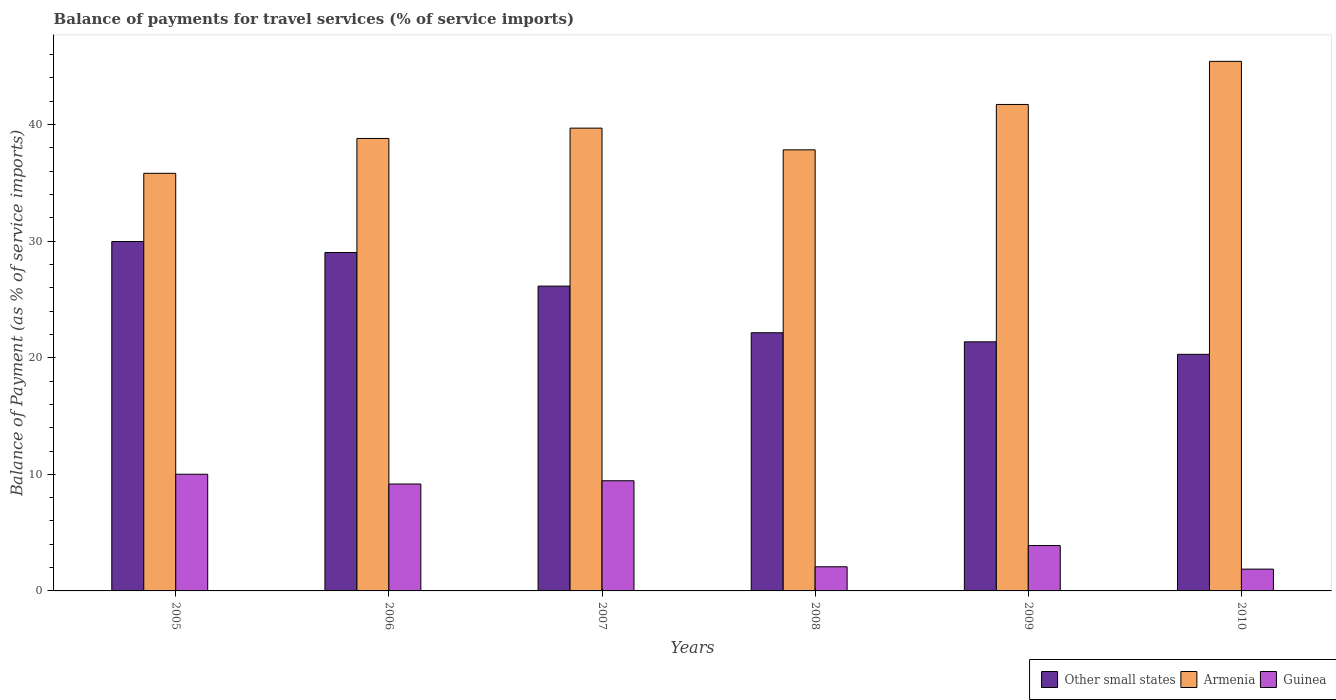How many different coloured bars are there?
Provide a short and direct response. 3. Are the number of bars per tick equal to the number of legend labels?
Keep it short and to the point. Yes. What is the label of the 5th group of bars from the left?
Your response must be concise. 2009. What is the balance of payments for travel services in Armenia in 2008?
Provide a short and direct response. 37.84. Across all years, what is the maximum balance of payments for travel services in Armenia?
Keep it short and to the point. 45.43. Across all years, what is the minimum balance of payments for travel services in Armenia?
Give a very brief answer. 35.82. What is the total balance of payments for travel services in Armenia in the graph?
Your answer should be compact. 239.32. What is the difference between the balance of payments for travel services in Guinea in 2006 and that in 2007?
Keep it short and to the point. -0.28. What is the difference between the balance of payments for travel services in Armenia in 2005 and the balance of payments for travel services in Guinea in 2006?
Provide a short and direct response. 26.65. What is the average balance of payments for travel services in Armenia per year?
Your answer should be compact. 39.89. In the year 2007, what is the difference between the balance of payments for travel services in Other small states and balance of payments for travel services in Armenia?
Your response must be concise. -13.55. In how many years, is the balance of payments for travel services in Other small states greater than 20 %?
Make the answer very short. 6. What is the ratio of the balance of payments for travel services in Armenia in 2006 to that in 2009?
Your answer should be compact. 0.93. Is the difference between the balance of payments for travel services in Other small states in 2009 and 2010 greater than the difference between the balance of payments for travel services in Armenia in 2009 and 2010?
Give a very brief answer. Yes. What is the difference between the highest and the second highest balance of payments for travel services in Armenia?
Offer a very short reply. 3.7. What is the difference between the highest and the lowest balance of payments for travel services in Armenia?
Ensure brevity in your answer.  9.6. In how many years, is the balance of payments for travel services in Other small states greater than the average balance of payments for travel services in Other small states taken over all years?
Provide a succinct answer. 3. Is the sum of the balance of payments for travel services in Armenia in 2005 and 2006 greater than the maximum balance of payments for travel services in Guinea across all years?
Provide a short and direct response. Yes. What does the 2nd bar from the left in 2008 represents?
Your answer should be compact. Armenia. What does the 2nd bar from the right in 2008 represents?
Provide a short and direct response. Armenia. What is the difference between two consecutive major ticks on the Y-axis?
Provide a short and direct response. 10. Are the values on the major ticks of Y-axis written in scientific E-notation?
Provide a short and direct response. No. Does the graph contain grids?
Offer a very short reply. No. Where does the legend appear in the graph?
Keep it short and to the point. Bottom right. How many legend labels are there?
Offer a very short reply. 3. What is the title of the graph?
Your answer should be very brief. Balance of payments for travel services (% of service imports). Does "Panama" appear as one of the legend labels in the graph?
Ensure brevity in your answer.  No. What is the label or title of the Y-axis?
Your answer should be compact. Balance of Payment (as % of service imports). What is the Balance of Payment (as % of service imports) of Other small states in 2005?
Ensure brevity in your answer.  29.97. What is the Balance of Payment (as % of service imports) of Armenia in 2005?
Make the answer very short. 35.82. What is the Balance of Payment (as % of service imports) of Guinea in 2005?
Ensure brevity in your answer.  10.01. What is the Balance of Payment (as % of service imports) of Other small states in 2006?
Provide a short and direct response. 29.03. What is the Balance of Payment (as % of service imports) in Armenia in 2006?
Your response must be concise. 38.81. What is the Balance of Payment (as % of service imports) of Guinea in 2006?
Your answer should be compact. 9.17. What is the Balance of Payment (as % of service imports) in Other small states in 2007?
Provide a short and direct response. 26.15. What is the Balance of Payment (as % of service imports) of Armenia in 2007?
Your answer should be very brief. 39.7. What is the Balance of Payment (as % of service imports) of Guinea in 2007?
Offer a very short reply. 9.45. What is the Balance of Payment (as % of service imports) of Other small states in 2008?
Give a very brief answer. 22.15. What is the Balance of Payment (as % of service imports) in Armenia in 2008?
Make the answer very short. 37.84. What is the Balance of Payment (as % of service imports) of Guinea in 2008?
Your answer should be very brief. 2.07. What is the Balance of Payment (as % of service imports) of Other small states in 2009?
Offer a very short reply. 21.37. What is the Balance of Payment (as % of service imports) of Armenia in 2009?
Offer a very short reply. 41.73. What is the Balance of Payment (as % of service imports) in Guinea in 2009?
Keep it short and to the point. 3.89. What is the Balance of Payment (as % of service imports) in Other small states in 2010?
Make the answer very short. 20.3. What is the Balance of Payment (as % of service imports) in Armenia in 2010?
Your response must be concise. 45.43. What is the Balance of Payment (as % of service imports) in Guinea in 2010?
Your answer should be compact. 1.87. Across all years, what is the maximum Balance of Payment (as % of service imports) of Other small states?
Your response must be concise. 29.97. Across all years, what is the maximum Balance of Payment (as % of service imports) of Armenia?
Your answer should be very brief. 45.43. Across all years, what is the maximum Balance of Payment (as % of service imports) of Guinea?
Your answer should be compact. 10.01. Across all years, what is the minimum Balance of Payment (as % of service imports) of Other small states?
Provide a succinct answer. 20.3. Across all years, what is the minimum Balance of Payment (as % of service imports) in Armenia?
Your response must be concise. 35.82. Across all years, what is the minimum Balance of Payment (as % of service imports) in Guinea?
Provide a succinct answer. 1.87. What is the total Balance of Payment (as % of service imports) in Other small states in the graph?
Make the answer very short. 148.96. What is the total Balance of Payment (as % of service imports) of Armenia in the graph?
Your answer should be compact. 239.32. What is the total Balance of Payment (as % of service imports) of Guinea in the graph?
Keep it short and to the point. 36.46. What is the difference between the Balance of Payment (as % of service imports) in Other small states in 2005 and that in 2006?
Offer a very short reply. 0.94. What is the difference between the Balance of Payment (as % of service imports) in Armenia in 2005 and that in 2006?
Offer a very short reply. -2.99. What is the difference between the Balance of Payment (as % of service imports) in Guinea in 2005 and that in 2006?
Make the answer very short. 0.84. What is the difference between the Balance of Payment (as % of service imports) in Other small states in 2005 and that in 2007?
Your answer should be compact. 3.83. What is the difference between the Balance of Payment (as % of service imports) in Armenia in 2005 and that in 2007?
Give a very brief answer. -3.88. What is the difference between the Balance of Payment (as % of service imports) in Guinea in 2005 and that in 2007?
Provide a short and direct response. 0.56. What is the difference between the Balance of Payment (as % of service imports) of Other small states in 2005 and that in 2008?
Offer a very short reply. 7.83. What is the difference between the Balance of Payment (as % of service imports) in Armenia in 2005 and that in 2008?
Your answer should be compact. -2.01. What is the difference between the Balance of Payment (as % of service imports) of Guinea in 2005 and that in 2008?
Ensure brevity in your answer.  7.94. What is the difference between the Balance of Payment (as % of service imports) in Other small states in 2005 and that in 2009?
Make the answer very short. 8.61. What is the difference between the Balance of Payment (as % of service imports) in Armenia in 2005 and that in 2009?
Ensure brevity in your answer.  -5.91. What is the difference between the Balance of Payment (as % of service imports) in Guinea in 2005 and that in 2009?
Offer a terse response. 6.12. What is the difference between the Balance of Payment (as % of service imports) in Other small states in 2005 and that in 2010?
Ensure brevity in your answer.  9.68. What is the difference between the Balance of Payment (as % of service imports) in Armenia in 2005 and that in 2010?
Provide a short and direct response. -9.6. What is the difference between the Balance of Payment (as % of service imports) of Guinea in 2005 and that in 2010?
Keep it short and to the point. 8.14. What is the difference between the Balance of Payment (as % of service imports) in Other small states in 2006 and that in 2007?
Provide a short and direct response. 2.88. What is the difference between the Balance of Payment (as % of service imports) in Armenia in 2006 and that in 2007?
Provide a short and direct response. -0.89. What is the difference between the Balance of Payment (as % of service imports) in Guinea in 2006 and that in 2007?
Your answer should be compact. -0.28. What is the difference between the Balance of Payment (as % of service imports) of Other small states in 2006 and that in 2008?
Your response must be concise. 6.88. What is the difference between the Balance of Payment (as % of service imports) of Armenia in 2006 and that in 2008?
Provide a short and direct response. 0.98. What is the difference between the Balance of Payment (as % of service imports) in Guinea in 2006 and that in 2008?
Your response must be concise. 7.1. What is the difference between the Balance of Payment (as % of service imports) in Other small states in 2006 and that in 2009?
Your answer should be very brief. 7.67. What is the difference between the Balance of Payment (as % of service imports) in Armenia in 2006 and that in 2009?
Your response must be concise. -2.92. What is the difference between the Balance of Payment (as % of service imports) of Guinea in 2006 and that in 2009?
Make the answer very short. 5.28. What is the difference between the Balance of Payment (as % of service imports) in Other small states in 2006 and that in 2010?
Provide a short and direct response. 8.73. What is the difference between the Balance of Payment (as % of service imports) of Armenia in 2006 and that in 2010?
Your answer should be very brief. -6.61. What is the difference between the Balance of Payment (as % of service imports) in Guinea in 2006 and that in 2010?
Your response must be concise. 7.3. What is the difference between the Balance of Payment (as % of service imports) of Other small states in 2007 and that in 2008?
Keep it short and to the point. 4. What is the difference between the Balance of Payment (as % of service imports) in Armenia in 2007 and that in 2008?
Give a very brief answer. 1.86. What is the difference between the Balance of Payment (as % of service imports) in Guinea in 2007 and that in 2008?
Your response must be concise. 7.38. What is the difference between the Balance of Payment (as % of service imports) of Other small states in 2007 and that in 2009?
Keep it short and to the point. 4.78. What is the difference between the Balance of Payment (as % of service imports) in Armenia in 2007 and that in 2009?
Make the answer very short. -2.03. What is the difference between the Balance of Payment (as % of service imports) in Guinea in 2007 and that in 2009?
Offer a terse response. 5.56. What is the difference between the Balance of Payment (as % of service imports) in Other small states in 2007 and that in 2010?
Your answer should be compact. 5.85. What is the difference between the Balance of Payment (as % of service imports) in Armenia in 2007 and that in 2010?
Your answer should be very brief. -5.73. What is the difference between the Balance of Payment (as % of service imports) of Guinea in 2007 and that in 2010?
Provide a short and direct response. 7.58. What is the difference between the Balance of Payment (as % of service imports) in Other small states in 2008 and that in 2009?
Keep it short and to the point. 0.78. What is the difference between the Balance of Payment (as % of service imports) in Armenia in 2008 and that in 2009?
Your answer should be compact. -3.89. What is the difference between the Balance of Payment (as % of service imports) of Guinea in 2008 and that in 2009?
Your answer should be very brief. -1.82. What is the difference between the Balance of Payment (as % of service imports) of Other small states in 2008 and that in 2010?
Keep it short and to the point. 1.85. What is the difference between the Balance of Payment (as % of service imports) of Armenia in 2008 and that in 2010?
Provide a short and direct response. -7.59. What is the difference between the Balance of Payment (as % of service imports) in Guinea in 2008 and that in 2010?
Your response must be concise. 0.2. What is the difference between the Balance of Payment (as % of service imports) in Other small states in 2009 and that in 2010?
Your answer should be compact. 1.07. What is the difference between the Balance of Payment (as % of service imports) of Armenia in 2009 and that in 2010?
Keep it short and to the point. -3.7. What is the difference between the Balance of Payment (as % of service imports) of Guinea in 2009 and that in 2010?
Your answer should be compact. 2.02. What is the difference between the Balance of Payment (as % of service imports) in Other small states in 2005 and the Balance of Payment (as % of service imports) in Armenia in 2006?
Your answer should be compact. -8.84. What is the difference between the Balance of Payment (as % of service imports) of Other small states in 2005 and the Balance of Payment (as % of service imports) of Guinea in 2006?
Offer a terse response. 20.8. What is the difference between the Balance of Payment (as % of service imports) in Armenia in 2005 and the Balance of Payment (as % of service imports) in Guinea in 2006?
Keep it short and to the point. 26.65. What is the difference between the Balance of Payment (as % of service imports) of Other small states in 2005 and the Balance of Payment (as % of service imports) of Armenia in 2007?
Make the answer very short. -9.72. What is the difference between the Balance of Payment (as % of service imports) of Other small states in 2005 and the Balance of Payment (as % of service imports) of Guinea in 2007?
Make the answer very short. 20.52. What is the difference between the Balance of Payment (as % of service imports) in Armenia in 2005 and the Balance of Payment (as % of service imports) in Guinea in 2007?
Keep it short and to the point. 26.37. What is the difference between the Balance of Payment (as % of service imports) of Other small states in 2005 and the Balance of Payment (as % of service imports) of Armenia in 2008?
Your answer should be compact. -7.86. What is the difference between the Balance of Payment (as % of service imports) in Other small states in 2005 and the Balance of Payment (as % of service imports) in Guinea in 2008?
Offer a very short reply. 27.9. What is the difference between the Balance of Payment (as % of service imports) in Armenia in 2005 and the Balance of Payment (as % of service imports) in Guinea in 2008?
Your answer should be compact. 33.75. What is the difference between the Balance of Payment (as % of service imports) of Other small states in 2005 and the Balance of Payment (as % of service imports) of Armenia in 2009?
Provide a short and direct response. -11.76. What is the difference between the Balance of Payment (as % of service imports) of Other small states in 2005 and the Balance of Payment (as % of service imports) of Guinea in 2009?
Make the answer very short. 26.08. What is the difference between the Balance of Payment (as % of service imports) in Armenia in 2005 and the Balance of Payment (as % of service imports) in Guinea in 2009?
Provide a succinct answer. 31.93. What is the difference between the Balance of Payment (as % of service imports) of Other small states in 2005 and the Balance of Payment (as % of service imports) of Armenia in 2010?
Ensure brevity in your answer.  -15.45. What is the difference between the Balance of Payment (as % of service imports) of Other small states in 2005 and the Balance of Payment (as % of service imports) of Guinea in 2010?
Offer a terse response. 28.1. What is the difference between the Balance of Payment (as % of service imports) in Armenia in 2005 and the Balance of Payment (as % of service imports) in Guinea in 2010?
Your answer should be compact. 33.95. What is the difference between the Balance of Payment (as % of service imports) in Other small states in 2006 and the Balance of Payment (as % of service imports) in Armenia in 2007?
Provide a succinct answer. -10.67. What is the difference between the Balance of Payment (as % of service imports) of Other small states in 2006 and the Balance of Payment (as % of service imports) of Guinea in 2007?
Give a very brief answer. 19.58. What is the difference between the Balance of Payment (as % of service imports) in Armenia in 2006 and the Balance of Payment (as % of service imports) in Guinea in 2007?
Make the answer very short. 29.36. What is the difference between the Balance of Payment (as % of service imports) of Other small states in 2006 and the Balance of Payment (as % of service imports) of Armenia in 2008?
Ensure brevity in your answer.  -8.81. What is the difference between the Balance of Payment (as % of service imports) of Other small states in 2006 and the Balance of Payment (as % of service imports) of Guinea in 2008?
Offer a terse response. 26.96. What is the difference between the Balance of Payment (as % of service imports) of Armenia in 2006 and the Balance of Payment (as % of service imports) of Guinea in 2008?
Make the answer very short. 36.74. What is the difference between the Balance of Payment (as % of service imports) of Other small states in 2006 and the Balance of Payment (as % of service imports) of Armenia in 2009?
Your answer should be very brief. -12.7. What is the difference between the Balance of Payment (as % of service imports) in Other small states in 2006 and the Balance of Payment (as % of service imports) in Guinea in 2009?
Your answer should be compact. 25.14. What is the difference between the Balance of Payment (as % of service imports) of Armenia in 2006 and the Balance of Payment (as % of service imports) of Guinea in 2009?
Your answer should be very brief. 34.92. What is the difference between the Balance of Payment (as % of service imports) of Other small states in 2006 and the Balance of Payment (as % of service imports) of Armenia in 2010?
Your answer should be very brief. -16.4. What is the difference between the Balance of Payment (as % of service imports) of Other small states in 2006 and the Balance of Payment (as % of service imports) of Guinea in 2010?
Your answer should be very brief. 27.16. What is the difference between the Balance of Payment (as % of service imports) of Armenia in 2006 and the Balance of Payment (as % of service imports) of Guinea in 2010?
Make the answer very short. 36.94. What is the difference between the Balance of Payment (as % of service imports) of Other small states in 2007 and the Balance of Payment (as % of service imports) of Armenia in 2008?
Offer a very short reply. -11.69. What is the difference between the Balance of Payment (as % of service imports) of Other small states in 2007 and the Balance of Payment (as % of service imports) of Guinea in 2008?
Your answer should be compact. 24.08. What is the difference between the Balance of Payment (as % of service imports) in Armenia in 2007 and the Balance of Payment (as % of service imports) in Guinea in 2008?
Offer a terse response. 37.63. What is the difference between the Balance of Payment (as % of service imports) of Other small states in 2007 and the Balance of Payment (as % of service imports) of Armenia in 2009?
Provide a succinct answer. -15.58. What is the difference between the Balance of Payment (as % of service imports) in Other small states in 2007 and the Balance of Payment (as % of service imports) in Guinea in 2009?
Offer a very short reply. 22.26. What is the difference between the Balance of Payment (as % of service imports) in Armenia in 2007 and the Balance of Payment (as % of service imports) in Guinea in 2009?
Keep it short and to the point. 35.81. What is the difference between the Balance of Payment (as % of service imports) in Other small states in 2007 and the Balance of Payment (as % of service imports) in Armenia in 2010?
Give a very brief answer. -19.28. What is the difference between the Balance of Payment (as % of service imports) in Other small states in 2007 and the Balance of Payment (as % of service imports) in Guinea in 2010?
Make the answer very short. 24.28. What is the difference between the Balance of Payment (as % of service imports) of Armenia in 2007 and the Balance of Payment (as % of service imports) of Guinea in 2010?
Provide a succinct answer. 37.83. What is the difference between the Balance of Payment (as % of service imports) of Other small states in 2008 and the Balance of Payment (as % of service imports) of Armenia in 2009?
Make the answer very short. -19.58. What is the difference between the Balance of Payment (as % of service imports) in Other small states in 2008 and the Balance of Payment (as % of service imports) in Guinea in 2009?
Offer a very short reply. 18.25. What is the difference between the Balance of Payment (as % of service imports) in Armenia in 2008 and the Balance of Payment (as % of service imports) in Guinea in 2009?
Your answer should be compact. 33.94. What is the difference between the Balance of Payment (as % of service imports) of Other small states in 2008 and the Balance of Payment (as % of service imports) of Armenia in 2010?
Provide a short and direct response. -23.28. What is the difference between the Balance of Payment (as % of service imports) of Other small states in 2008 and the Balance of Payment (as % of service imports) of Guinea in 2010?
Offer a terse response. 20.28. What is the difference between the Balance of Payment (as % of service imports) in Armenia in 2008 and the Balance of Payment (as % of service imports) in Guinea in 2010?
Ensure brevity in your answer.  35.97. What is the difference between the Balance of Payment (as % of service imports) of Other small states in 2009 and the Balance of Payment (as % of service imports) of Armenia in 2010?
Offer a terse response. -24.06. What is the difference between the Balance of Payment (as % of service imports) in Other small states in 2009 and the Balance of Payment (as % of service imports) in Guinea in 2010?
Make the answer very short. 19.49. What is the difference between the Balance of Payment (as % of service imports) in Armenia in 2009 and the Balance of Payment (as % of service imports) in Guinea in 2010?
Offer a very short reply. 39.86. What is the average Balance of Payment (as % of service imports) in Other small states per year?
Give a very brief answer. 24.83. What is the average Balance of Payment (as % of service imports) of Armenia per year?
Keep it short and to the point. 39.89. What is the average Balance of Payment (as % of service imports) of Guinea per year?
Your answer should be compact. 6.08. In the year 2005, what is the difference between the Balance of Payment (as % of service imports) of Other small states and Balance of Payment (as % of service imports) of Armenia?
Keep it short and to the point. -5.85. In the year 2005, what is the difference between the Balance of Payment (as % of service imports) in Other small states and Balance of Payment (as % of service imports) in Guinea?
Give a very brief answer. 19.97. In the year 2005, what is the difference between the Balance of Payment (as % of service imports) in Armenia and Balance of Payment (as % of service imports) in Guinea?
Your answer should be compact. 25.81. In the year 2006, what is the difference between the Balance of Payment (as % of service imports) of Other small states and Balance of Payment (as % of service imports) of Armenia?
Offer a terse response. -9.78. In the year 2006, what is the difference between the Balance of Payment (as % of service imports) of Other small states and Balance of Payment (as % of service imports) of Guinea?
Your response must be concise. 19.86. In the year 2006, what is the difference between the Balance of Payment (as % of service imports) in Armenia and Balance of Payment (as % of service imports) in Guinea?
Provide a short and direct response. 29.64. In the year 2007, what is the difference between the Balance of Payment (as % of service imports) in Other small states and Balance of Payment (as % of service imports) in Armenia?
Offer a very short reply. -13.55. In the year 2007, what is the difference between the Balance of Payment (as % of service imports) of Other small states and Balance of Payment (as % of service imports) of Guinea?
Your response must be concise. 16.7. In the year 2007, what is the difference between the Balance of Payment (as % of service imports) of Armenia and Balance of Payment (as % of service imports) of Guinea?
Offer a terse response. 30.25. In the year 2008, what is the difference between the Balance of Payment (as % of service imports) of Other small states and Balance of Payment (as % of service imports) of Armenia?
Provide a short and direct response. -15.69. In the year 2008, what is the difference between the Balance of Payment (as % of service imports) of Other small states and Balance of Payment (as % of service imports) of Guinea?
Your response must be concise. 20.08. In the year 2008, what is the difference between the Balance of Payment (as % of service imports) in Armenia and Balance of Payment (as % of service imports) in Guinea?
Your answer should be very brief. 35.77. In the year 2009, what is the difference between the Balance of Payment (as % of service imports) in Other small states and Balance of Payment (as % of service imports) in Armenia?
Give a very brief answer. -20.36. In the year 2009, what is the difference between the Balance of Payment (as % of service imports) of Other small states and Balance of Payment (as % of service imports) of Guinea?
Make the answer very short. 17.47. In the year 2009, what is the difference between the Balance of Payment (as % of service imports) in Armenia and Balance of Payment (as % of service imports) in Guinea?
Make the answer very short. 37.84. In the year 2010, what is the difference between the Balance of Payment (as % of service imports) in Other small states and Balance of Payment (as % of service imports) in Armenia?
Keep it short and to the point. -25.13. In the year 2010, what is the difference between the Balance of Payment (as % of service imports) in Other small states and Balance of Payment (as % of service imports) in Guinea?
Your answer should be compact. 18.43. In the year 2010, what is the difference between the Balance of Payment (as % of service imports) of Armenia and Balance of Payment (as % of service imports) of Guinea?
Provide a succinct answer. 43.56. What is the ratio of the Balance of Payment (as % of service imports) of Other small states in 2005 to that in 2006?
Your answer should be compact. 1.03. What is the ratio of the Balance of Payment (as % of service imports) in Armenia in 2005 to that in 2006?
Offer a terse response. 0.92. What is the ratio of the Balance of Payment (as % of service imports) in Guinea in 2005 to that in 2006?
Keep it short and to the point. 1.09. What is the ratio of the Balance of Payment (as % of service imports) in Other small states in 2005 to that in 2007?
Make the answer very short. 1.15. What is the ratio of the Balance of Payment (as % of service imports) in Armenia in 2005 to that in 2007?
Make the answer very short. 0.9. What is the ratio of the Balance of Payment (as % of service imports) in Guinea in 2005 to that in 2007?
Your answer should be compact. 1.06. What is the ratio of the Balance of Payment (as % of service imports) of Other small states in 2005 to that in 2008?
Make the answer very short. 1.35. What is the ratio of the Balance of Payment (as % of service imports) in Armenia in 2005 to that in 2008?
Provide a short and direct response. 0.95. What is the ratio of the Balance of Payment (as % of service imports) of Guinea in 2005 to that in 2008?
Ensure brevity in your answer.  4.83. What is the ratio of the Balance of Payment (as % of service imports) of Other small states in 2005 to that in 2009?
Your answer should be very brief. 1.4. What is the ratio of the Balance of Payment (as % of service imports) in Armenia in 2005 to that in 2009?
Your response must be concise. 0.86. What is the ratio of the Balance of Payment (as % of service imports) in Guinea in 2005 to that in 2009?
Your answer should be compact. 2.57. What is the ratio of the Balance of Payment (as % of service imports) of Other small states in 2005 to that in 2010?
Ensure brevity in your answer.  1.48. What is the ratio of the Balance of Payment (as % of service imports) of Armenia in 2005 to that in 2010?
Keep it short and to the point. 0.79. What is the ratio of the Balance of Payment (as % of service imports) of Guinea in 2005 to that in 2010?
Provide a short and direct response. 5.35. What is the ratio of the Balance of Payment (as % of service imports) of Other small states in 2006 to that in 2007?
Give a very brief answer. 1.11. What is the ratio of the Balance of Payment (as % of service imports) of Armenia in 2006 to that in 2007?
Your answer should be very brief. 0.98. What is the ratio of the Balance of Payment (as % of service imports) in Guinea in 2006 to that in 2007?
Keep it short and to the point. 0.97. What is the ratio of the Balance of Payment (as % of service imports) of Other small states in 2006 to that in 2008?
Provide a succinct answer. 1.31. What is the ratio of the Balance of Payment (as % of service imports) of Armenia in 2006 to that in 2008?
Keep it short and to the point. 1.03. What is the ratio of the Balance of Payment (as % of service imports) of Guinea in 2006 to that in 2008?
Give a very brief answer. 4.43. What is the ratio of the Balance of Payment (as % of service imports) of Other small states in 2006 to that in 2009?
Offer a very short reply. 1.36. What is the ratio of the Balance of Payment (as % of service imports) of Armenia in 2006 to that in 2009?
Offer a very short reply. 0.93. What is the ratio of the Balance of Payment (as % of service imports) in Guinea in 2006 to that in 2009?
Your answer should be compact. 2.36. What is the ratio of the Balance of Payment (as % of service imports) in Other small states in 2006 to that in 2010?
Your answer should be compact. 1.43. What is the ratio of the Balance of Payment (as % of service imports) in Armenia in 2006 to that in 2010?
Your answer should be compact. 0.85. What is the ratio of the Balance of Payment (as % of service imports) in Guinea in 2006 to that in 2010?
Keep it short and to the point. 4.9. What is the ratio of the Balance of Payment (as % of service imports) in Other small states in 2007 to that in 2008?
Your answer should be compact. 1.18. What is the ratio of the Balance of Payment (as % of service imports) in Armenia in 2007 to that in 2008?
Provide a succinct answer. 1.05. What is the ratio of the Balance of Payment (as % of service imports) of Guinea in 2007 to that in 2008?
Give a very brief answer. 4.56. What is the ratio of the Balance of Payment (as % of service imports) of Other small states in 2007 to that in 2009?
Your answer should be very brief. 1.22. What is the ratio of the Balance of Payment (as % of service imports) in Armenia in 2007 to that in 2009?
Offer a very short reply. 0.95. What is the ratio of the Balance of Payment (as % of service imports) in Guinea in 2007 to that in 2009?
Ensure brevity in your answer.  2.43. What is the ratio of the Balance of Payment (as % of service imports) of Other small states in 2007 to that in 2010?
Keep it short and to the point. 1.29. What is the ratio of the Balance of Payment (as % of service imports) in Armenia in 2007 to that in 2010?
Make the answer very short. 0.87. What is the ratio of the Balance of Payment (as % of service imports) of Guinea in 2007 to that in 2010?
Your answer should be compact. 5.05. What is the ratio of the Balance of Payment (as % of service imports) of Other small states in 2008 to that in 2009?
Offer a terse response. 1.04. What is the ratio of the Balance of Payment (as % of service imports) of Armenia in 2008 to that in 2009?
Ensure brevity in your answer.  0.91. What is the ratio of the Balance of Payment (as % of service imports) in Guinea in 2008 to that in 2009?
Your response must be concise. 0.53. What is the ratio of the Balance of Payment (as % of service imports) in Other small states in 2008 to that in 2010?
Your answer should be very brief. 1.09. What is the ratio of the Balance of Payment (as % of service imports) of Armenia in 2008 to that in 2010?
Give a very brief answer. 0.83. What is the ratio of the Balance of Payment (as % of service imports) of Guinea in 2008 to that in 2010?
Your response must be concise. 1.11. What is the ratio of the Balance of Payment (as % of service imports) of Other small states in 2009 to that in 2010?
Offer a terse response. 1.05. What is the ratio of the Balance of Payment (as % of service imports) of Armenia in 2009 to that in 2010?
Your answer should be very brief. 0.92. What is the ratio of the Balance of Payment (as % of service imports) in Guinea in 2009 to that in 2010?
Your response must be concise. 2.08. What is the difference between the highest and the second highest Balance of Payment (as % of service imports) of Other small states?
Your answer should be compact. 0.94. What is the difference between the highest and the second highest Balance of Payment (as % of service imports) in Armenia?
Provide a short and direct response. 3.7. What is the difference between the highest and the second highest Balance of Payment (as % of service imports) in Guinea?
Keep it short and to the point. 0.56. What is the difference between the highest and the lowest Balance of Payment (as % of service imports) of Other small states?
Your answer should be very brief. 9.68. What is the difference between the highest and the lowest Balance of Payment (as % of service imports) of Armenia?
Provide a short and direct response. 9.6. What is the difference between the highest and the lowest Balance of Payment (as % of service imports) of Guinea?
Give a very brief answer. 8.14. 